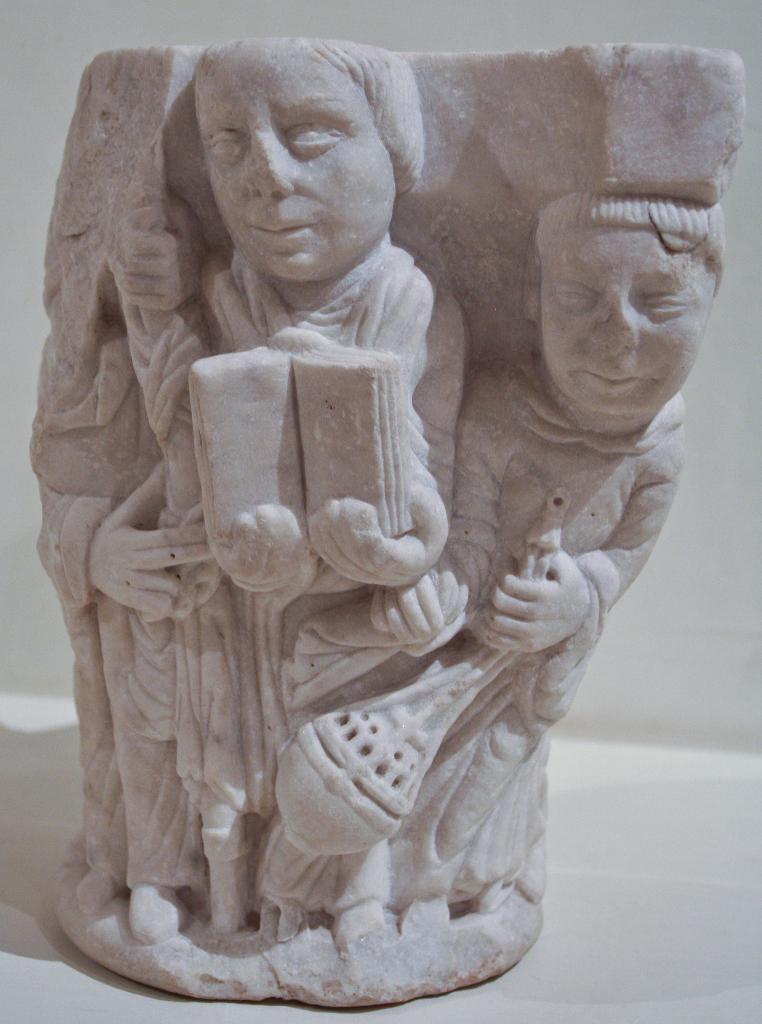Could you give a brief overview of what you see in this image? In this picture we can see a sculpture in the front, there is a wall in the background. 